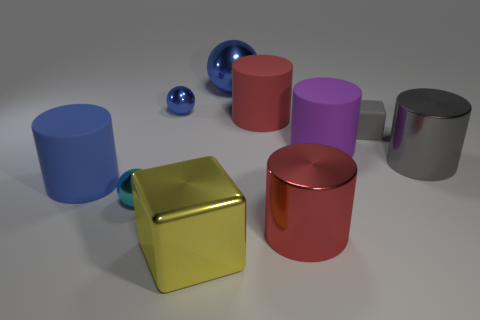Subtract all yellow cylinders. Subtract all yellow balls. How many cylinders are left? 5 Subtract all spheres. How many objects are left? 7 Subtract 0 purple cubes. How many objects are left? 10 Subtract all small cyan objects. Subtract all small things. How many objects are left? 6 Add 2 big blue cylinders. How many big blue cylinders are left? 3 Add 9 big red rubber cylinders. How many big red rubber cylinders exist? 10 